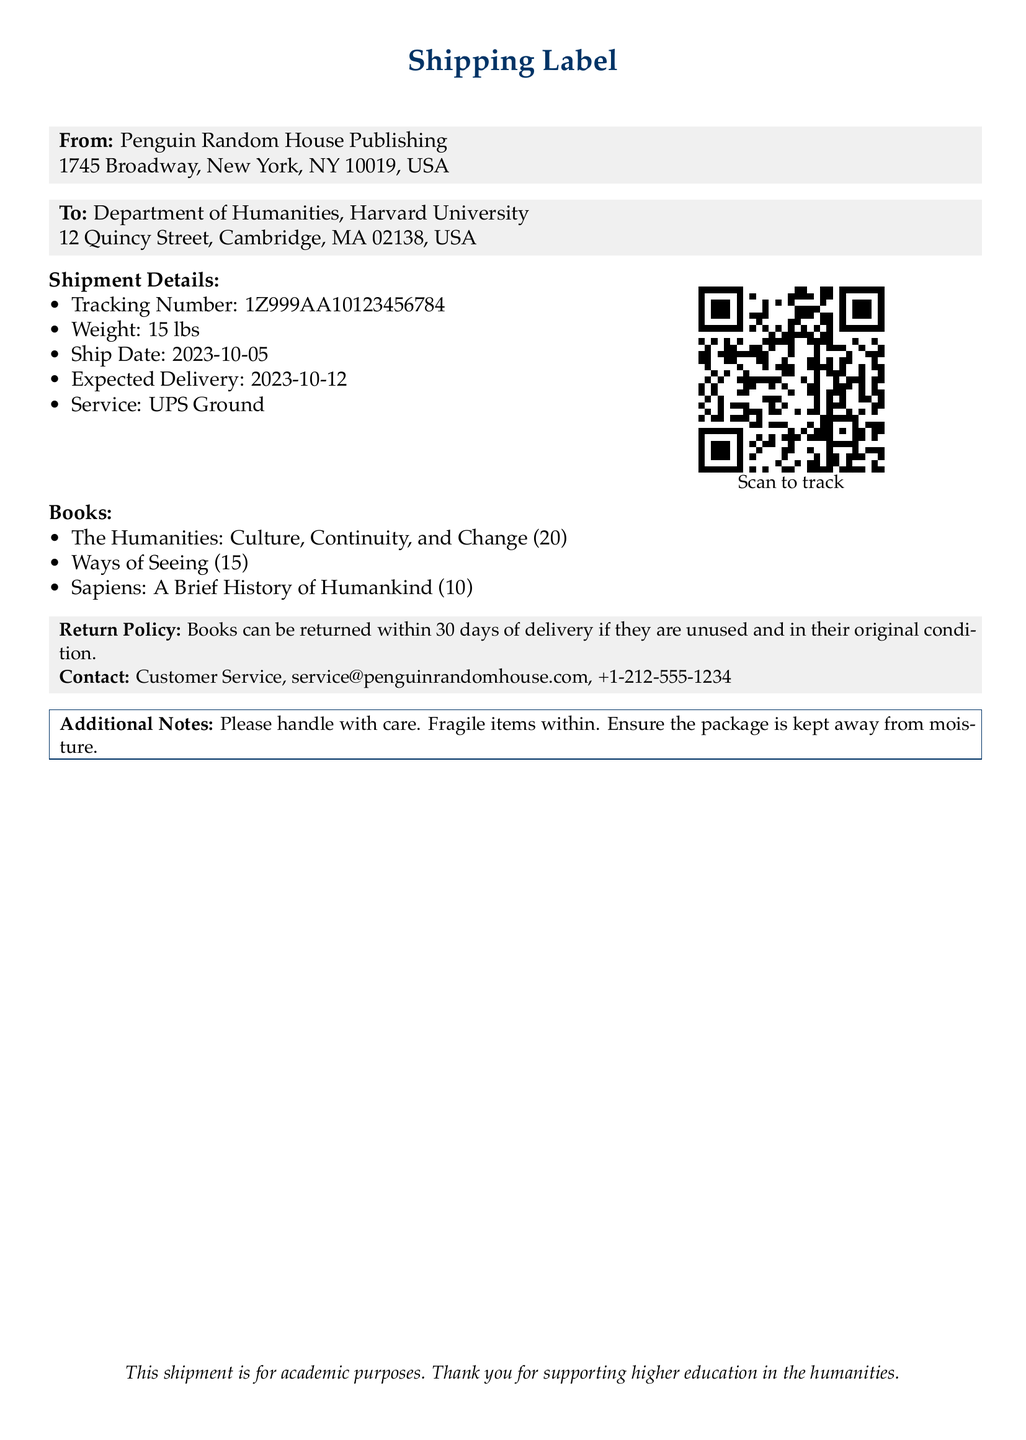What is the shipping date? The shipping date is provided in the shipment details section of the shipping label.
Answer: 2023-10-05 How many copies of "The Humanities: Culture, Continuity, and Change" were ordered? The quantity of the book is listed under the books section of the shipping label.
Answer: 20 What is the expected delivery date? The expected delivery date is indicated in the shipment details of the document.
Answer: 2023-10-12 What is the weight of the shipment? The weight is mentioned in the shipment details.
Answer: 15 lbs What is the tracking number? The tracking number can be found in the shipment details section of the label.
Answer: 1Z999AA10123456784 What is the return policy duration? The return policy is stated in the return policy section of the shipping label, specifying how long books can be returned.
Answer: 30 days What should be done to track the package? Tracking instructions are mentioned through a QR code with a reference to scanning for tracking.
Answer: Scan to track Who is the sender of the shipment? The sender's information is provided at the top of the shipping label.
Answer: Penguin Random House Publishing What is the contact email for customer service? The email for customer service is stated in the contact section of the document.
Answer: service@penguinrandomhouse.com 